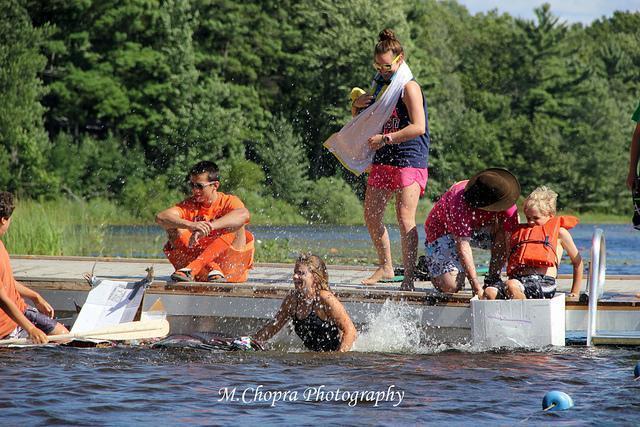How many boats are there?
Give a very brief answer. 2. How many people are there?
Give a very brief answer. 6. 